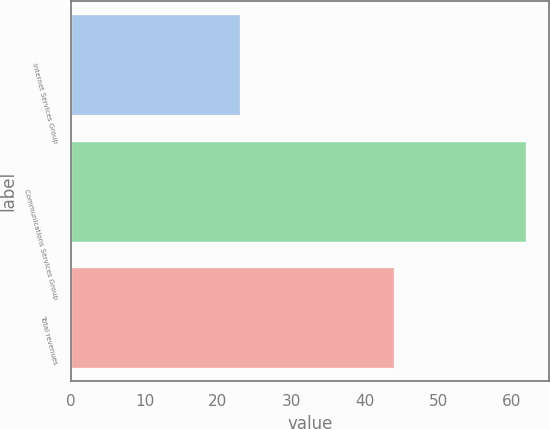Convert chart to OTSL. <chart><loc_0><loc_0><loc_500><loc_500><bar_chart><fcel>Internet Services Group<fcel>Communications Services Group<fcel>Total revenues<nl><fcel>23<fcel>62<fcel>44<nl></chart> 